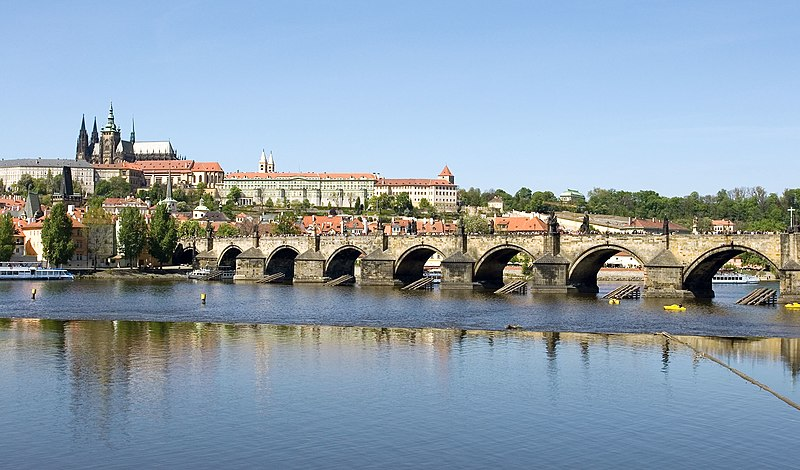Can you describe the main features of this image for me? The image captures the historic Charles Bridge, a prominent landmark in Prague, Czech Republic. The bridge, constructed of stone, spans the tranquil waters of the Vltava River. It's adorned with a series of statues, adding to its historical significance. The perspective of the image is from a distance, allowing a comprehensive view of the entire length of the bridge and its surroundings. 

The surrounding landscape is dotted with buildings of varying architectural styles and colors, their red and orange rooftops adding a splash of color to the scene. The calm water of the river mirrors the bridge and the buildings, creating a beautiful reflection. Above, the sky is a clear blue, providing a vibrant backdrop to the scene. The image is a testament to the architectural grandeur and historical richness of Prague. 